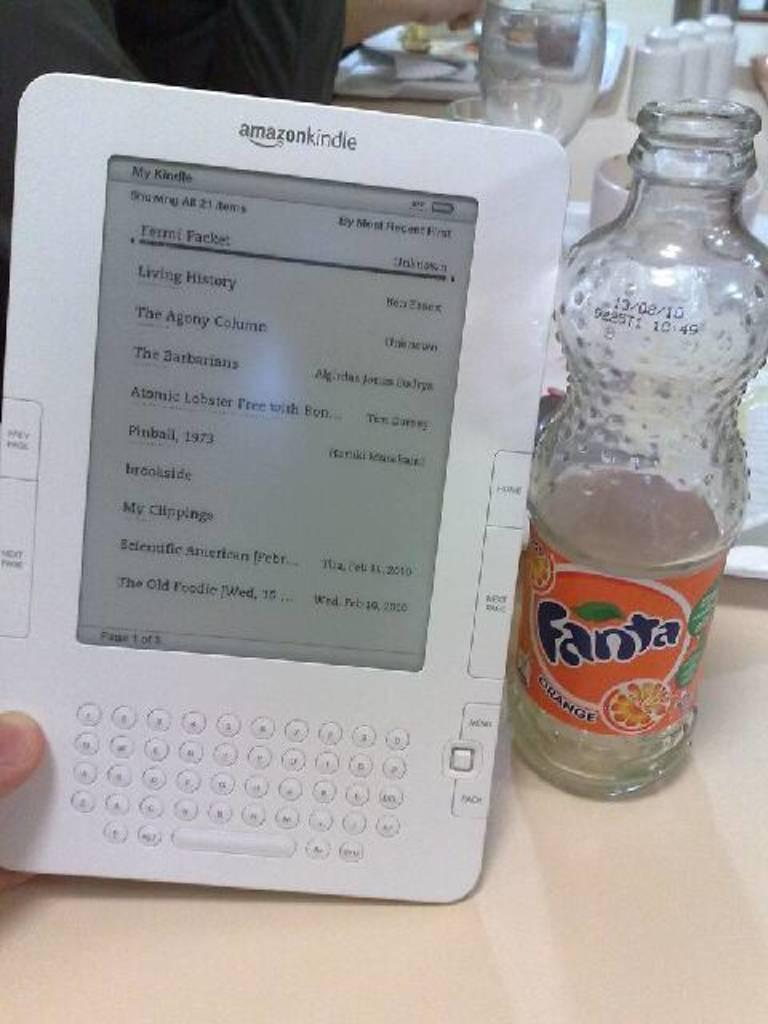<image>
Provide a brief description of the given image. Empty bottle of Fanta orange soda and an Amazon Kindle display screen. 